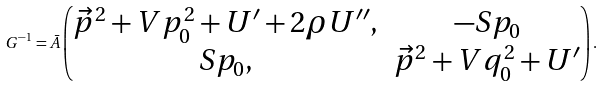<formula> <loc_0><loc_0><loc_500><loc_500>G ^ { - 1 } = \bar { A } \begin{pmatrix} \vec { p } ^ { 2 } + V p _ { 0 } ^ { 2 } + U ^ { \prime } + 2 \rho U ^ { \prime \prime } , & - S p _ { 0 } \\ S p _ { 0 } , & \vec { p } ^ { 2 } + V q _ { 0 } ^ { 2 } + U ^ { \prime } \end{pmatrix} .</formula> 